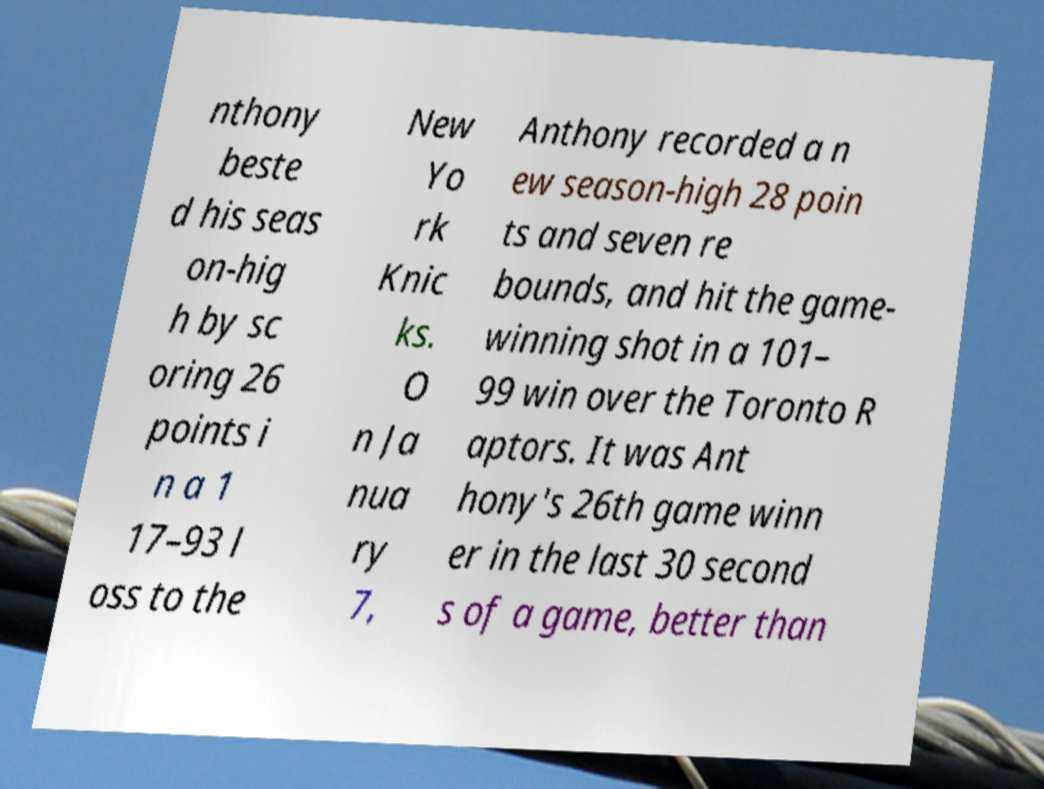Please read and relay the text visible in this image. What does it say? nthony beste d his seas on-hig h by sc oring 26 points i n a 1 17–93 l oss to the New Yo rk Knic ks. O n Ja nua ry 7, Anthony recorded a n ew season-high 28 poin ts and seven re bounds, and hit the game- winning shot in a 101– 99 win over the Toronto R aptors. It was Ant hony's 26th game winn er in the last 30 second s of a game, better than 